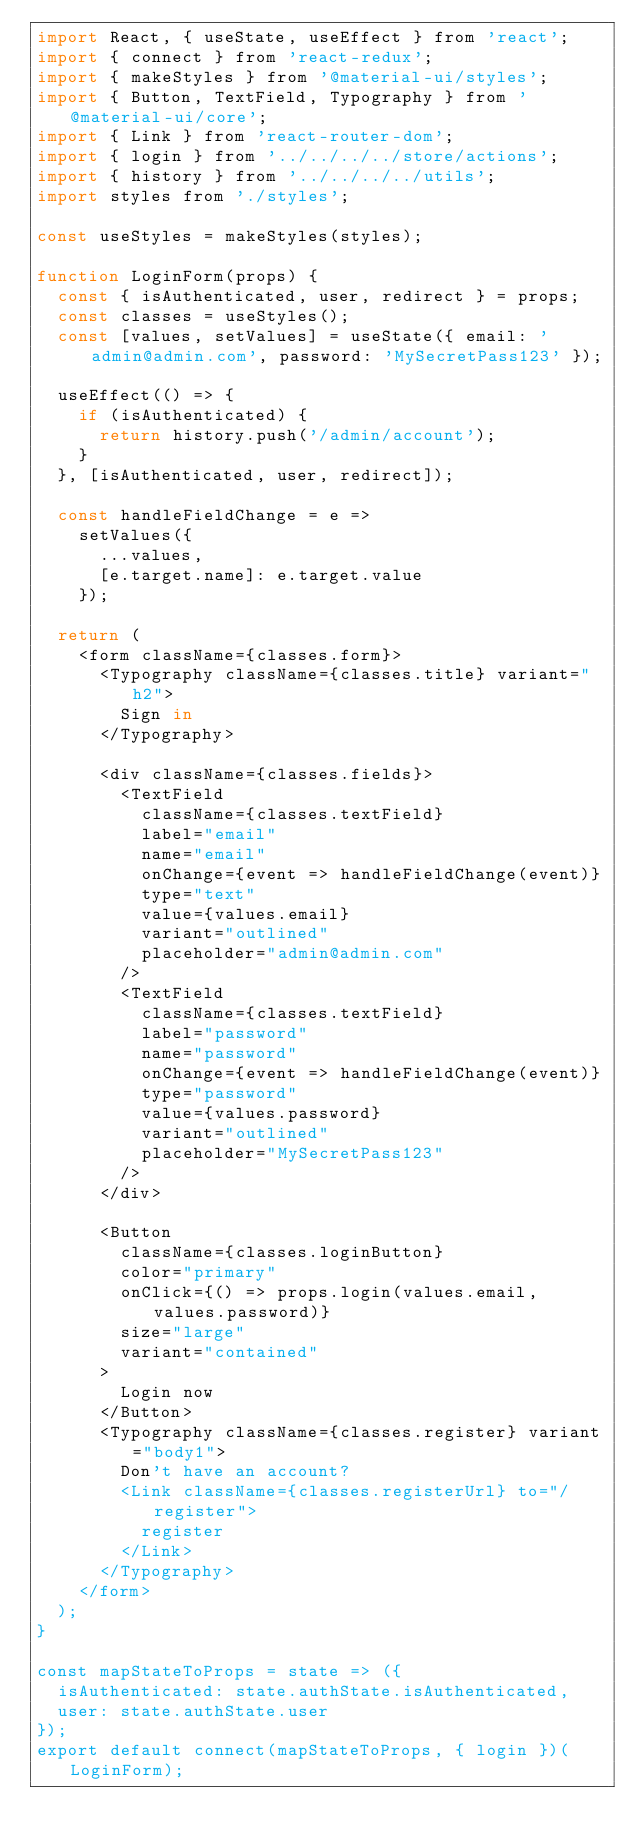Convert code to text. <code><loc_0><loc_0><loc_500><loc_500><_JavaScript_>import React, { useState, useEffect } from 'react';
import { connect } from 'react-redux';
import { makeStyles } from '@material-ui/styles';
import { Button, TextField, Typography } from '@material-ui/core';
import { Link } from 'react-router-dom';
import { login } from '../../../../store/actions';
import { history } from '../../../../utils';
import styles from './styles';

const useStyles = makeStyles(styles);

function LoginForm(props) {
  const { isAuthenticated, user, redirect } = props;
  const classes = useStyles();
  const [values, setValues] = useState({ email: 'admin@admin.com', password: 'MySecretPass123' });

  useEffect(() => {
    if (isAuthenticated) {
      return history.push('/admin/account');
    }
  }, [isAuthenticated, user, redirect]);

  const handleFieldChange = e =>
    setValues({
      ...values,
      [e.target.name]: e.target.value
    });

  return (
    <form className={classes.form}>
      <Typography className={classes.title} variant="h2">
        Sign in
      </Typography>

      <div className={classes.fields}>
        <TextField
          className={classes.textField}
          label="email"
          name="email"
          onChange={event => handleFieldChange(event)}
          type="text"
          value={values.email}
          variant="outlined"
          placeholder="admin@admin.com"
        />
        <TextField
          className={classes.textField}
          label="password"
          name="password"
          onChange={event => handleFieldChange(event)}
          type="password"
          value={values.password}
          variant="outlined"
          placeholder="MySecretPass123"
        />
      </div>

      <Button
        className={classes.loginButton}
        color="primary"
        onClick={() => props.login(values.email, values.password)}
        size="large"
        variant="contained"
      >
        Login now
      </Button>
      <Typography className={classes.register} variant="body1">
        Don't have an account?
        <Link className={classes.registerUrl} to="/register">
          register
        </Link>
      </Typography>
    </form>
  );
}

const mapStateToProps = state => ({
  isAuthenticated: state.authState.isAuthenticated,
  user: state.authState.user
});
export default connect(mapStateToProps, { login })(LoginForm);
</code> 